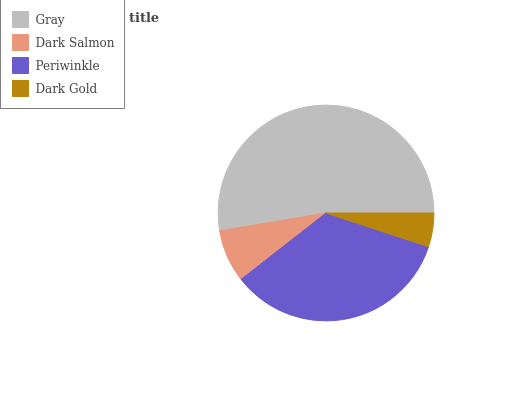Is Dark Gold the minimum?
Answer yes or no. Yes. Is Gray the maximum?
Answer yes or no. Yes. Is Dark Salmon the minimum?
Answer yes or no. No. Is Dark Salmon the maximum?
Answer yes or no. No. Is Gray greater than Dark Salmon?
Answer yes or no. Yes. Is Dark Salmon less than Gray?
Answer yes or no. Yes. Is Dark Salmon greater than Gray?
Answer yes or no. No. Is Gray less than Dark Salmon?
Answer yes or no. No. Is Periwinkle the high median?
Answer yes or no. Yes. Is Dark Salmon the low median?
Answer yes or no. Yes. Is Gray the high median?
Answer yes or no. No. Is Dark Gold the low median?
Answer yes or no. No. 